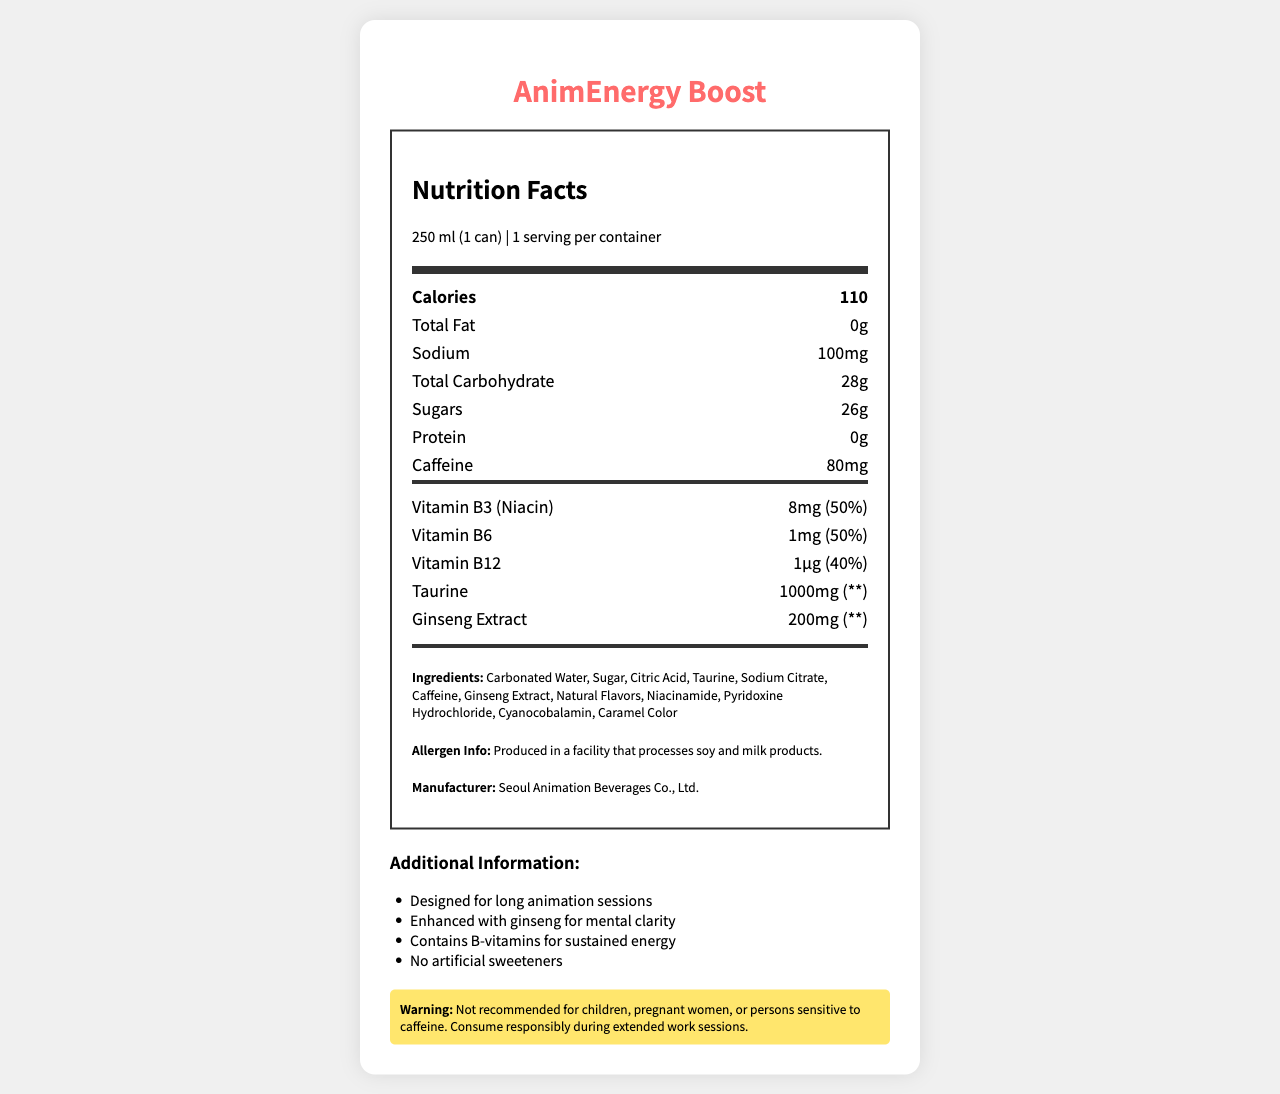who is the manufacturer of AnimEnergy Boost? The manufacturer information is listed under "Manufacturer" in the document.
Answer: Seoul Animation Beverages Co., Ltd. what is the serving size for AnimEnergy Boost? The serving size is specified in the document under "Nutrition Facts."
Answer: 250 ml (1 can) how much caffeine is in one serving of AnimEnergy Boost? The amount of caffeine is specified under the "Caffeine" section.
Answer: 80mg how many calories are in a single can of AnimEnergy Boost? The calorie count is listed under the "Calories" section.
Answer: 110 calories which vitamins are included in AnimEnergy Boost? The vitamins are listed under the "Vitamins and Minerals" section of the document.
Answer: Vitamin B3, Vitamin B6, Vitamin B12 what is the amount of Vitamin B12 in AnimEnergy Boost? The amount of Vitamin B12 is specified under the "Vitamins and Minerals" section.
Answer: 1µg how much sugar does AnimEnergy Boost contain per serving? The sugar content is listed under the "Sugars" section.
Answer: 26g how much taurine is included in a serving of AnimEnergy Boost? The amount of taurine is listed under the "Vitamins and Minerals" section.
Answer: 1000mg which of the following ingredients is NOT listed in AnimEnergy Boost? A. Taurine B. Ginseng Extract C. Aspartame The ingredients list does not include Aspartame; it includes Taurine and Ginseng Extract.
Answer: C what is the daily value percentage of Vitamin B6 in AnimEnergy Boost? A. 40% B. 50% C. 60% D. 70% The daily value percentage of Vitamin B6 is 50%, as listed under the "Vitamins and Minerals" section.
Answer: B is AnimEnergy Boost recommended for children or pregnant women? The document includes a warning that the product is not recommended for children, pregnant women, or persons sensitive to caffeine.
Answer: No summarize the purpose and contents of the AnimEnergy Boost label. The label is designed to inform consumers about the nutritional content and ingredients of AnimEnergy Boost, emphasize its suitability for long work sessions, and provide safety warnings.
Answer: The AnimEnergy Boost Nutrition Facts label provides detailed information about the energy drink designed for long animation sessions. It includes the serving size, calories, total fat, sodium, total carbohydrates, sugars, protein, caffeine, and specific vitamins and minerals like Vitamin B3, B6, B12, Taurine, and Ginseng Extract. It also lists the ingredients and allergen information, notes the manufacturer, and provides additional information on its purpose and benefits, along with a consumer warning. what is the percentage of daily value for sodium in one can of AnimEnergy Boost? The document does not provide the daily value percentage for sodium.
Answer: Not provided does AnimEnergy Boost contain any artificial sweeteners? The additional information section states that the product contains no artificial sweeteners.
Answer: No 